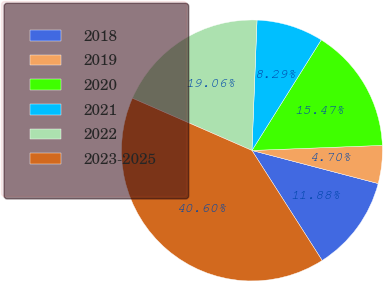Convert chart to OTSL. <chart><loc_0><loc_0><loc_500><loc_500><pie_chart><fcel>2018<fcel>2019<fcel>2020<fcel>2021<fcel>2022<fcel>2023-2025<nl><fcel>11.88%<fcel>4.7%<fcel>15.47%<fcel>8.29%<fcel>19.06%<fcel>40.6%<nl></chart> 